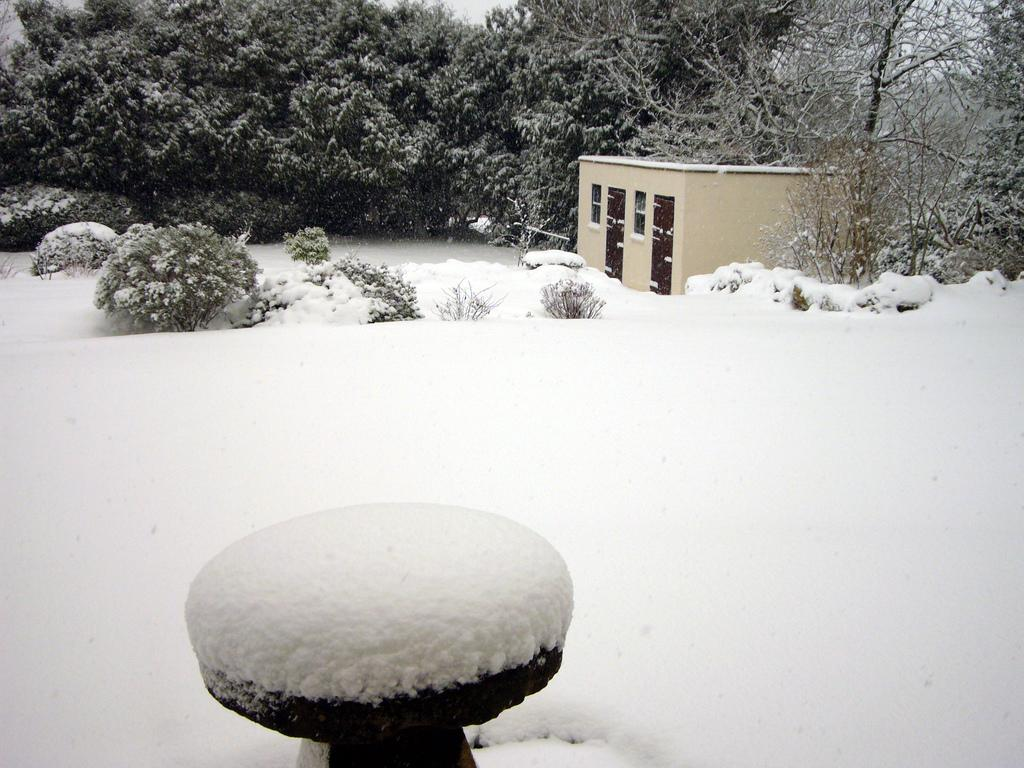What type of weather condition is depicted at the bottom of the image? There is snow at the bottom of the image. What type of vegetation can be seen in the image? There are plants in the image. What structure is located in the middle of the image? There is a house in the middle of the image. What can be seen in the background of the image? There are trees visible in the background of the image. How many giraffes are visible in the image? There are no giraffes present in the image. What type of bridge can be seen connecting the house to the trees? There is no bridge present in the image; it only features a house, trees, plants, and snow. 